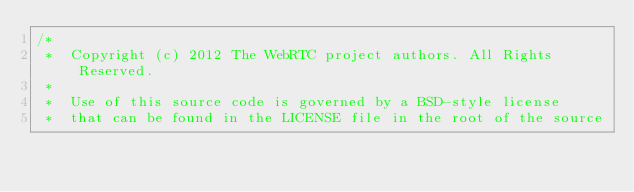Convert code to text. <code><loc_0><loc_0><loc_500><loc_500><_C++_>/*
 *  Copyright (c) 2012 The WebRTC project authors. All Rights Reserved.
 *
 *  Use of this source code is governed by a BSD-style license
 *  that can be found in the LICENSE file in the root of the source</code> 